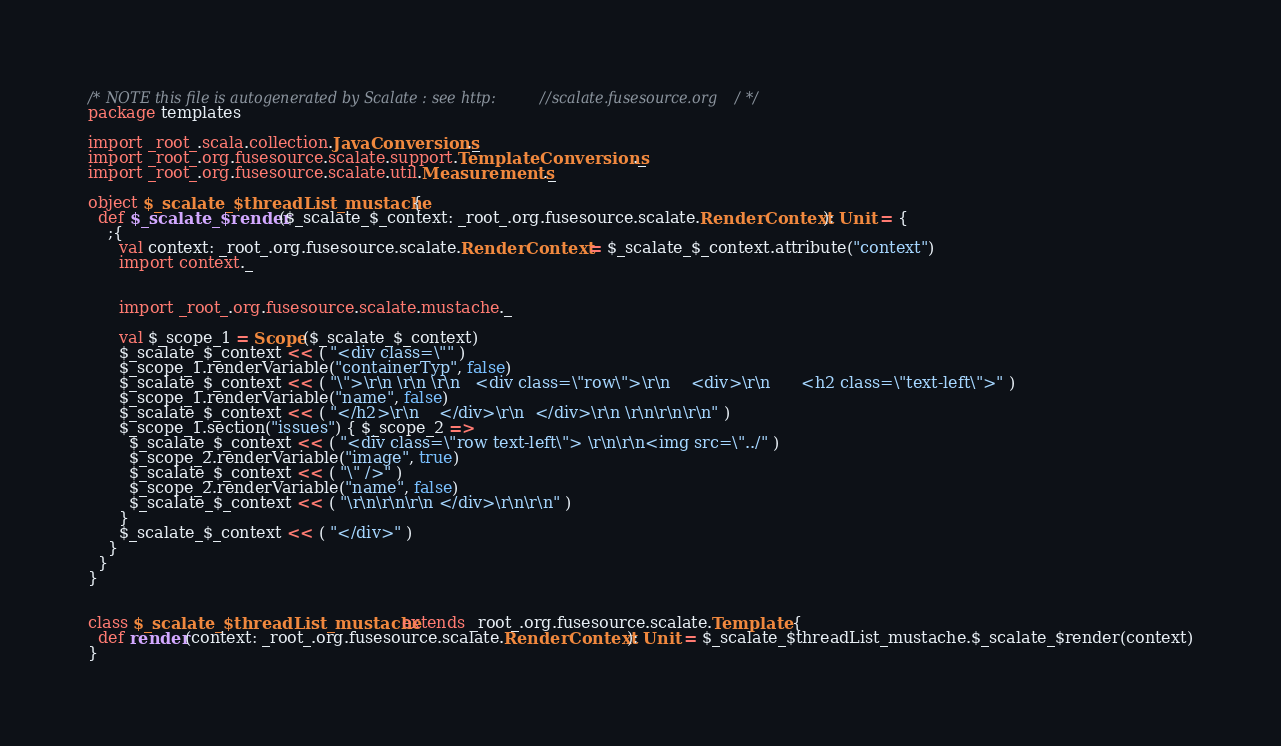Convert code to text. <code><loc_0><loc_0><loc_500><loc_500><_Scala_>/* NOTE this file is autogenerated by Scalate : see http://scalate.fusesource.org/ */
package templates

import _root_.scala.collection.JavaConversions._
import _root_.org.fusesource.scalate.support.TemplateConversions._
import _root_.org.fusesource.scalate.util.Measurements._

object $_scalate_$threadList_mustache {
  def $_scalate_$render($_scalate_$_context: _root_.org.fusesource.scalate.RenderContext): Unit = {
    ;{
      val context: _root_.org.fusesource.scalate.RenderContext = $_scalate_$_context.attribute("context")
      import context._
      
      
      import _root_.org.fusesource.scalate.mustache._
      
      val $_scope_1 = Scope($_scalate_$_context)
      $_scalate_$_context << ( "<div class=\"" )
      $_scope_1.renderVariable("containerTyp", false)
      $_scalate_$_context << ( "\">\r\n \r\n \r\n   <div class=\"row\">\r\n    <div>\r\n      <h2 class=\"text-left\">" )
      $_scope_1.renderVariable("name", false)
      $_scalate_$_context << ( "</h2>\r\n    </div>\r\n  </div>\r\n \r\n\r\n\r\n" )
      $_scope_1.section("issues") { $_scope_2 =>
        $_scalate_$_context << ( "<div class=\"row text-left\"> \r\n\r\n<img src=\"../" )
        $_scope_2.renderVariable("image", true)
        $_scalate_$_context << ( "\" />" )
        $_scope_2.renderVariable("name", false)
        $_scalate_$_context << ( "\r\n\r\n\r\n </div>\r\n\r\n" )
      }
      $_scalate_$_context << ( "</div>" )
    }
  }
}


class $_scalate_$threadList_mustache extends _root_.org.fusesource.scalate.Template {
  def render(context: _root_.org.fusesource.scalate.RenderContext): Unit = $_scalate_$threadList_mustache.$_scalate_$render(context)
}
</code> 